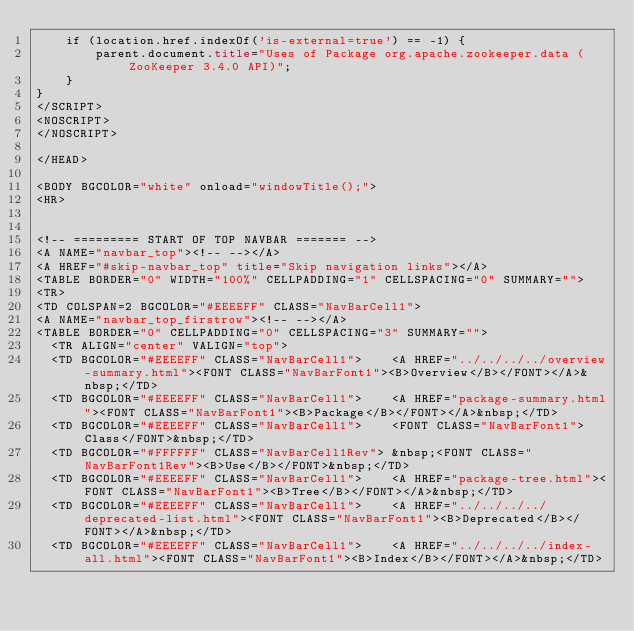Convert code to text. <code><loc_0><loc_0><loc_500><loc_500><_HTML_>    if (location.href.indexOf('is-external=true') == -1) {
        parent.document.title="Uses of Package org.apache.zookeeper.data (ZooKeeper 3.4.0 API)";
    }
}
</SCRIPT>
<NOSCRIPT>
</NOSCRIPT>

</HEAD>

<BODY BGCOLOR="white" onload="windowTitle();">
<HR>


<!-- ========= START OF TOP NAVBAR ======= -->
<A NAME="navbar_top"><!-- --></A>
<A HREF="#skip-navbar_top" title="Skip navigation links"></A>
<TABLE BORDER="0" WIDTH="100%" CELLPADDING="1" CELLSPACING="0" SUMMARY="">
<TR>
<TD COLSPAN=2 BGCOLOR="#EEEEFF" CLASS="NavBarCell1">
<A NAME="navbar_top_firstrow"><!-- --></A>
<TABLE BORDER="0" CELLPADDING="0" CELLSPACING="3" SUMMARY="">
  <TR ALIGN="center" VALIGN="top">
  <TD BGCOLOR="#EEEEFF" CLASS="NavBarCell1">    <A HREF="../../../../overview-summary.html"><FONT CLASS="NavBarFont1"><B>Overview</B></FONT></A>&nbsp;</TD>
  <TD BGCOLOR="#EEEEFF" CLASS="NavBarCell1">    <A HREF="package-summary.html"><FONT CLASS="NavBarFont1"><B>Package</B></FONT></A>&nbsp;</TD>
  <TD BGCOLOR="#EEEEFF" CLASS="NavBarCell1">    <FONT CLASS="NavBarFont1">Class</FONT>&nbsp;</TD>
  <TD BGCOLOR="#FFFFFF" CLASS="NavBarCell1Rev"> &nbsp;<FONT CLASS="NavBarFont1Rev"><B>Use</B></FONT>&nbsp;</TD>
  <TD BGCOLOR="#EEEEFF" CLASS="NavBarCell1">    <A HREF="package-tree.html"><FONT CLASS="NavBarFont1"><B>Tree</B></FONT></A>&nbsp;</TD>
  <TD BGCOLOR="#EEEEFF" CLASS="NavBarCell1">    <A HREF="../../../../deprecated-list.html"><FONT CLASS="NavBarFont1"><B>Deprecated</B></FONT></A>&nbsp;</TD>
  <TD BGCOLOR="#EEEEFF" CLASS="NavBarCell1">    <A HREF="../../../../index-all.html"><FONT CLASS="NavBarFont1"><B>Index</B></FONT></A>&nbsp;</TD></code> 